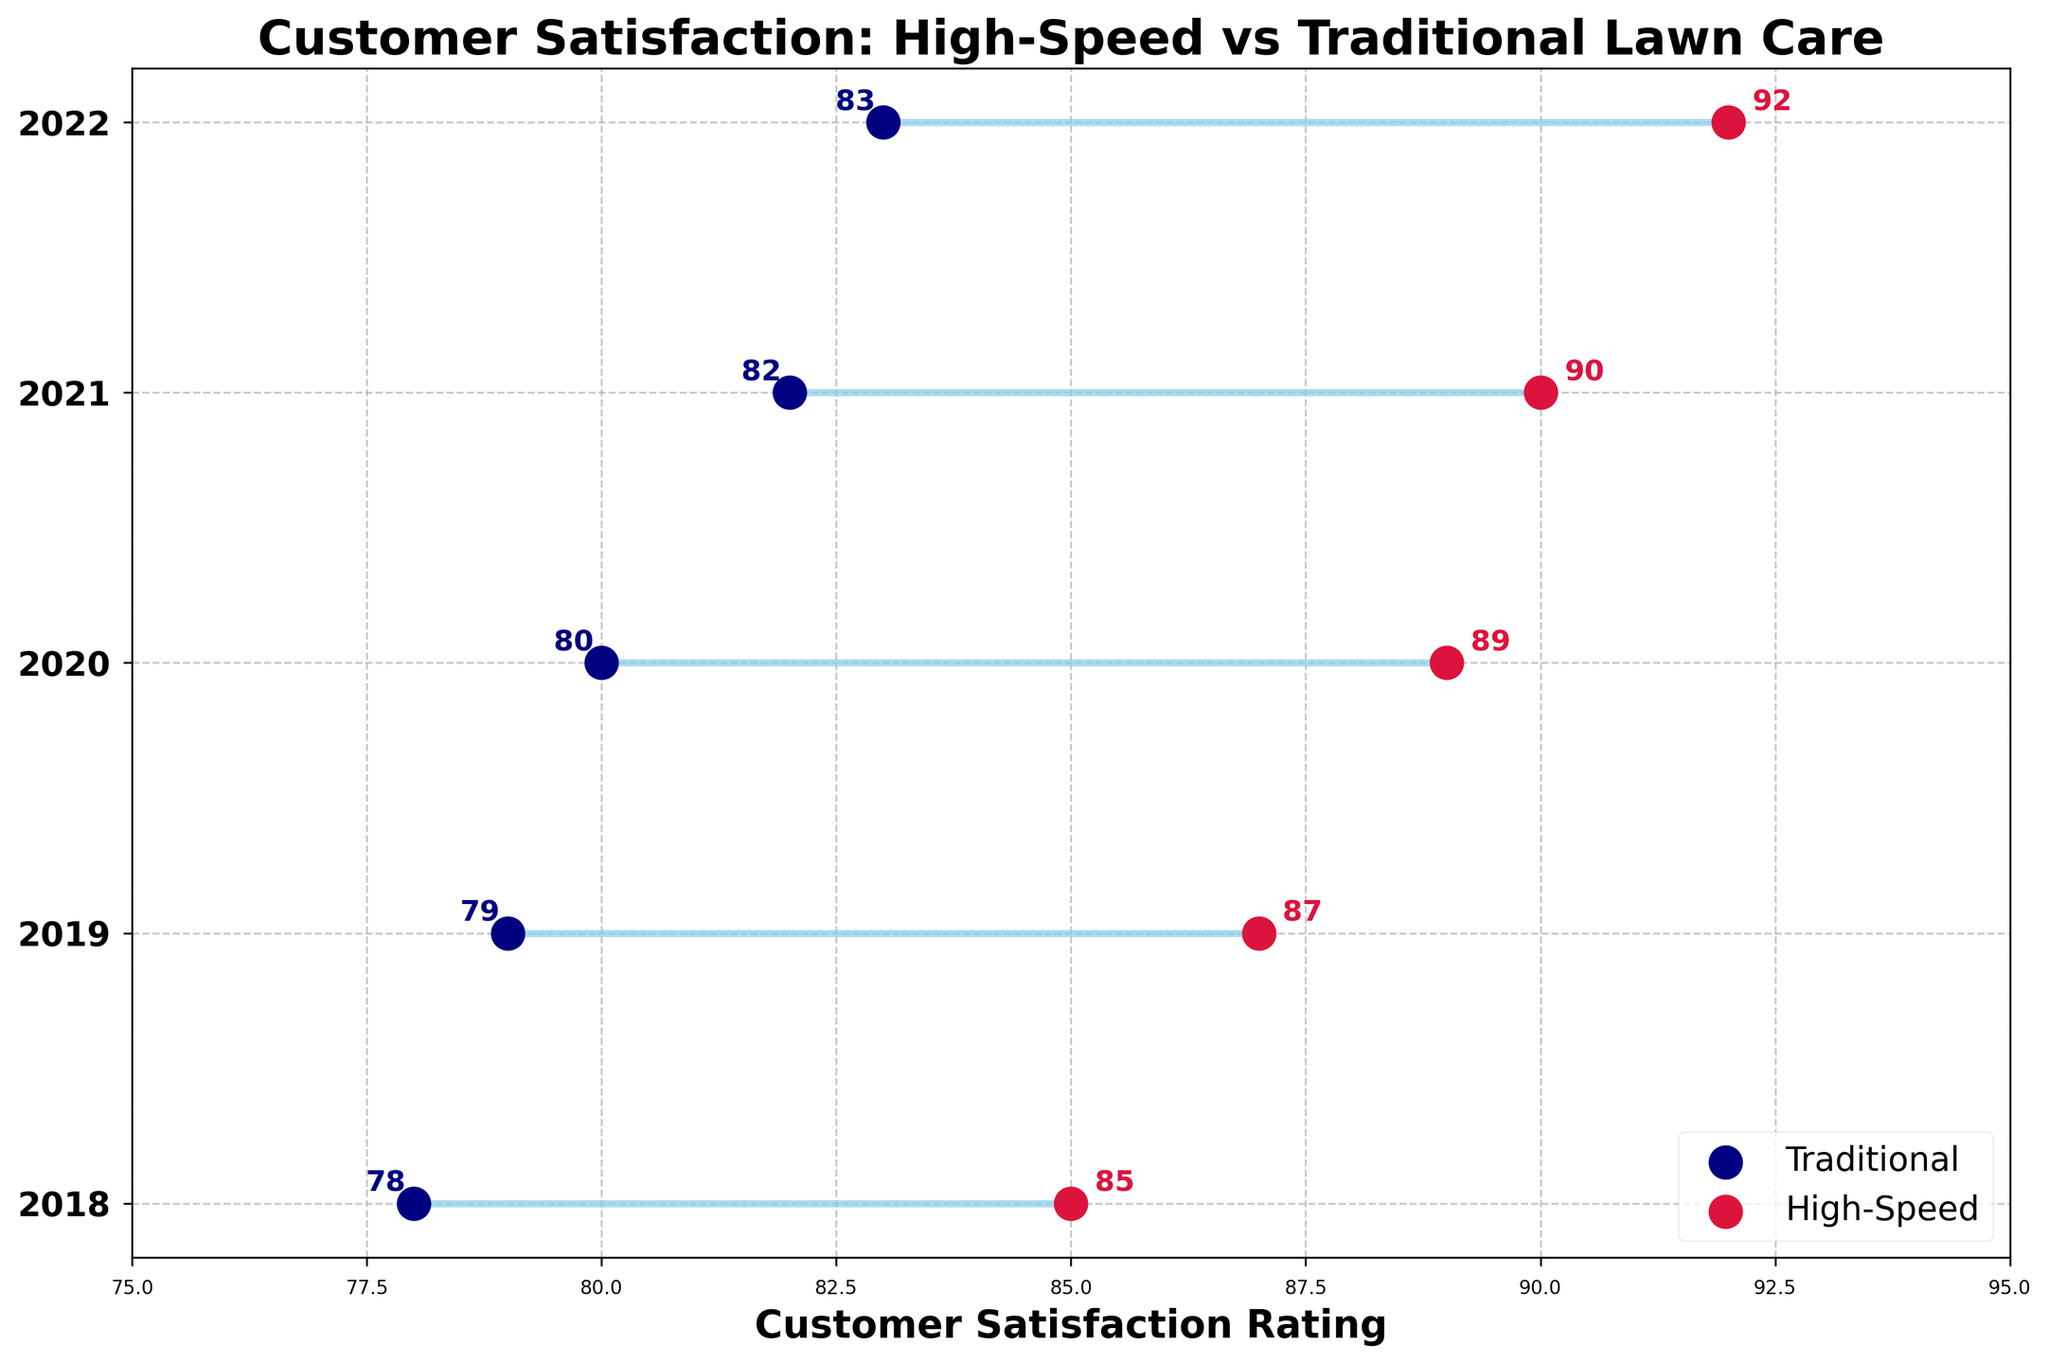What is the title of the figure? The title of the figure is located at the top and generally describes the main content of the plot. In this case, the title is "Customer Satisfaction: High-Speed vs Traditional Lawn Care".
Answer: Customer Satisfaction: High-Speed vs Traditional Lawn Care What are the years represented on the y-axis? The years represented on the y-axis are given as tick labels. They range from 2018 to 2022.
Answer: 2018, 2019, 2020, 2021, 2022 Which service type has the highest customer satisfaction rating in 2022? Look for the data points for the year 2022 on the y-axis and compare the ratings. High-Speed Lawn Care is rated higher at 92 than Traditional Lawn Care at 83.
Answer: High-Speed Lawn Care What is the difference in customer satisfaction ratings between High-Speed and Traditional Lawn Care in 2020? In 2020, the customer satisfaction rating for High-Speed Lawn Care is 89 and for Traditional Lawn Care, it is 80. The difference is calculated as 89 - 80.
Answer: 9 How did the customer satisfaction rating for Traditional Lawn Care change from 2018 to 2022? Compare the ratings for Traditional Lawn Care in 2018 and 2022. The rating increased from 78 to 83. The change is 83 - 78.
Answer: 5 What is the average customer satisfaction rating for High-Speed Lawn Care over the five years? To find the average, add the yearly ratings for High-Speed Lawn Care (85, 87, 89, 90, 92) and divide by the number of years (5). The sum is 85 + 87 + 89 + 90 + 92 = 443. The average is 443 / 5.
Answer: 88.6 Which year shows the smallest gap in customer satisfaction ratings between the two services? Calculate the difference in ratings for each year. The gaps are: 2018 = 85 - 78 = 7, 2019 = 87 - 79 = 8, 2020 = 89 - 80 = 9, 2021 = 90 - 82 = 8, 2022 = 92 - 83 = 9. The smallest gap is in 2018 with a difference of 7.
Answer: 2018 What is the overall trend in customer satisfaction for High-Speed Lawn Care from 2018 to 2022? Observing the ratings for High-Speed Lawn Care, they increase steadily from 85 in 2018 to 92 in 2022. This indicates an upward trend.
Answer: Upward trend Is there any year where Traditional Lawn Care's satisfaction rating is equal to or higher than High-Speed Lawn Care? Check the ratings for both services across all years. In all years, High-Speed Lawn Care has a higher rating than Traditional Lawn Care.
Answer: No What is the color used to represent High-Speed Lawn Care ratings in the plot? The color assigned to High-Speed Lawn Care ratings is noted by observing the corresponding data points, which are represented in crimson.
Answer: Crimson 